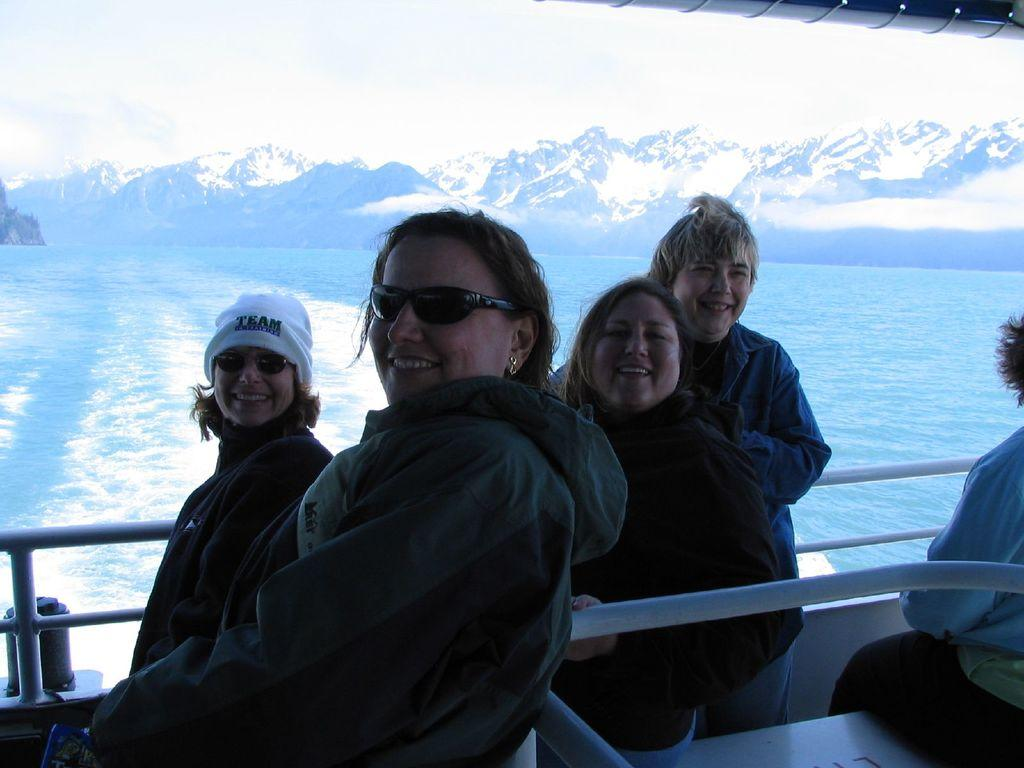What are the people in the image doing? There is a group of people in a boat in the image. Where is the boat located? The boat is on the surface of water. What can be seen in the background of the image? There are mountains in the background of the image. What is visible at the top of the image? The sky is visible at the top of the image. Can you see any bones in the water near the boat? There are no bones visible in the water near the boat. Are there any jellyfish swimming around the boat? There are no jellyfish visible in the image. 